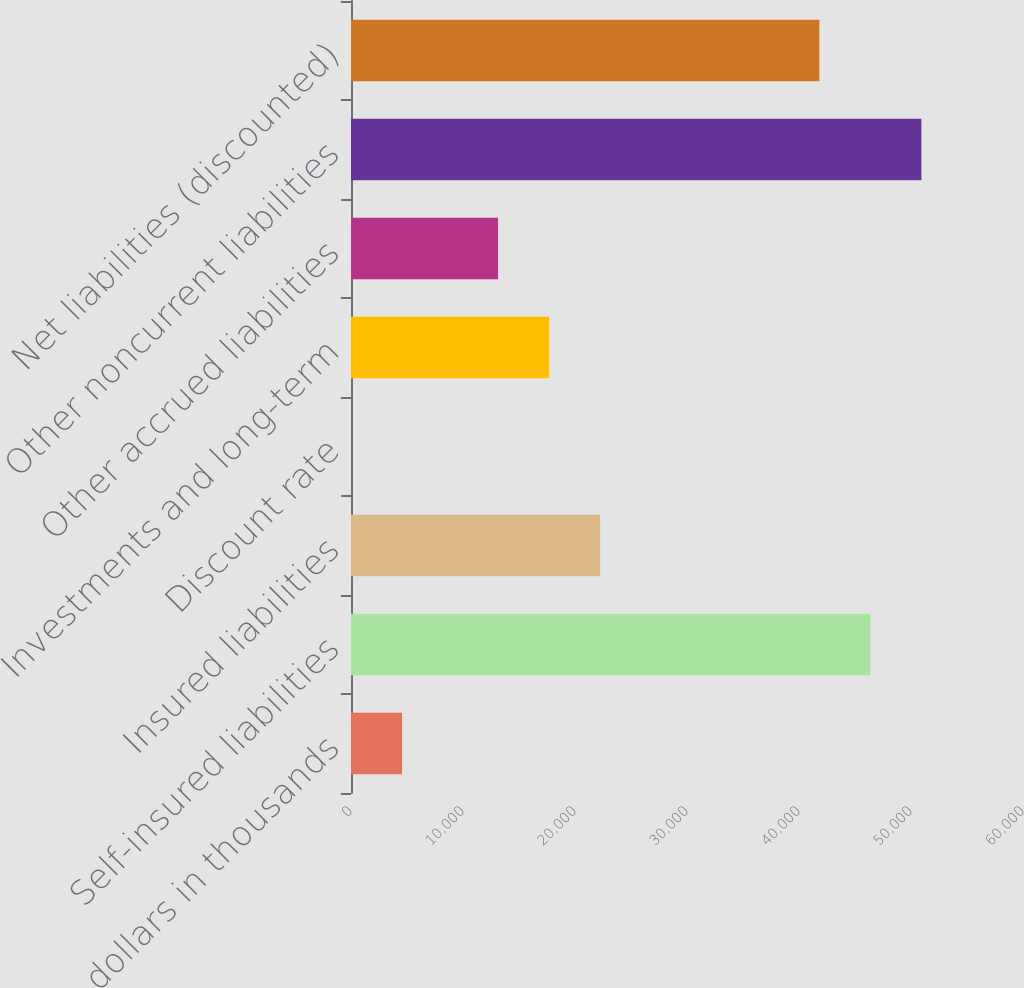Convert chart. <chart><loc_0><loc_0><loc_500><loc_500><bar_chart><fcel>dollars in thousands<fcel>Self-insured liabilities<fcel>Insured liabilities<fcel>Discount rate<fcel>Investments and long-term<fcel>Other accrued liabilities<fcel>Other noncurrent liabilities<fcel>Net liabilities (discounted)<nl><fcel>4558.06<fcel>46372.8<fcel>22244.5<fcel>1.29<fcel>17687.8<fcel>13131<fcel>50929.5<fcel>41816<nl></chart> 